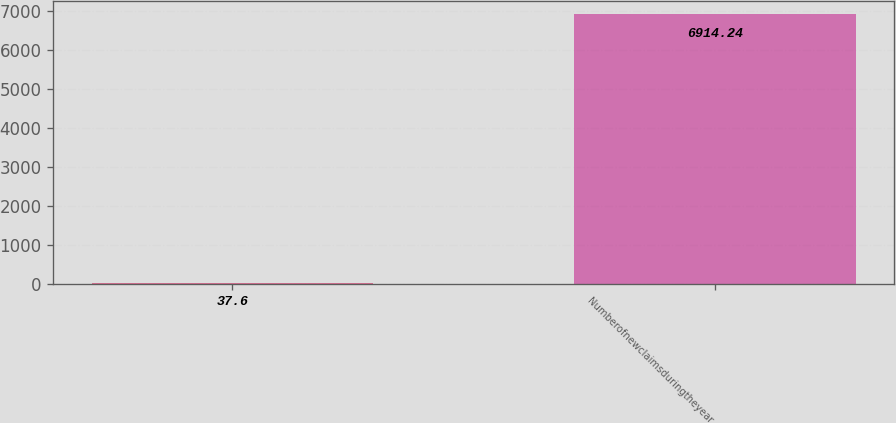Convert chart. <chart><loc_0><loc_0><loc_500><loc_500><bar_chart><ecel><fcel>Numberofnewclaimsduringtheyear<nl><fcel>37.6<fcel>6914.24<nl></chart> 